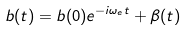Convert formula to latex. <formula><loc_0><loc_0><loc_500><loc_500>b ( t ) = b ( 0 ) e ^ { - i \omega _ { e } t } + \beta ( t )</formula> 